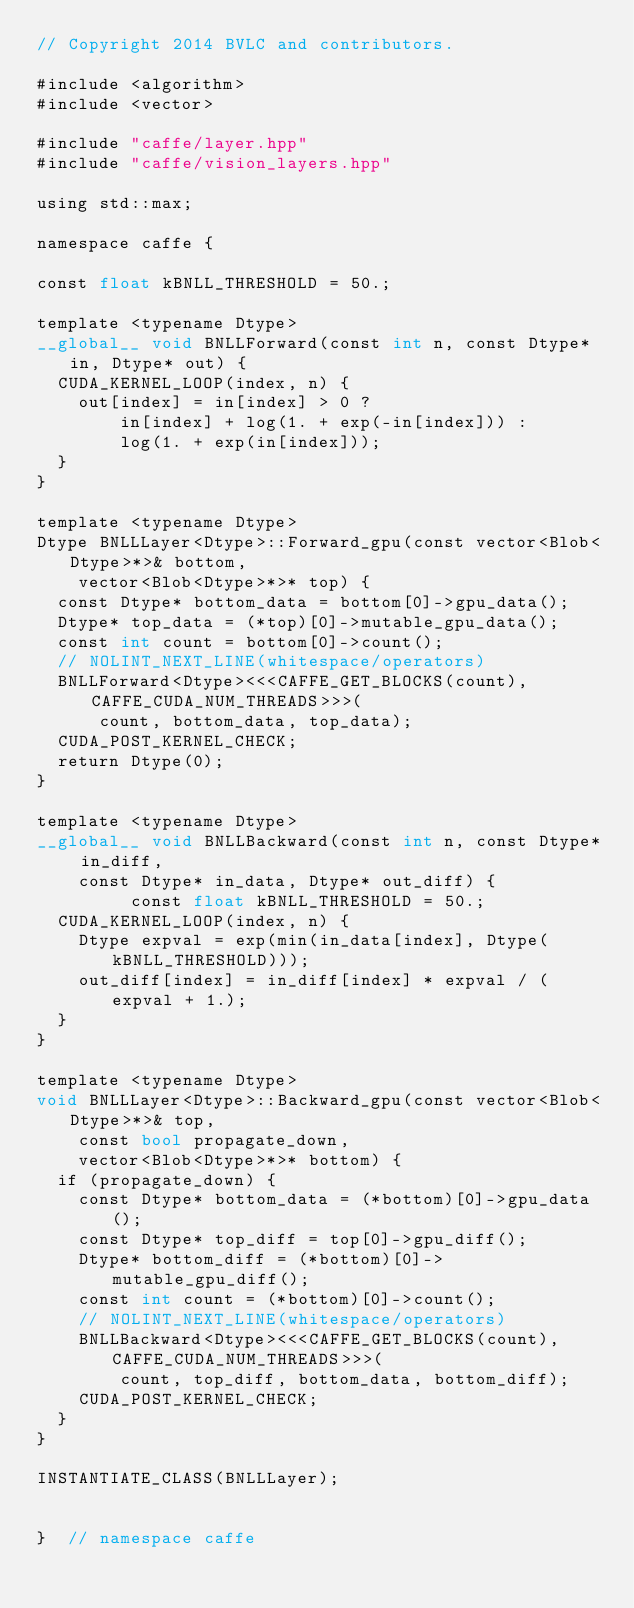<code> <loc_0><loc_0><loc_500><loc_500><_Cuda_>// Copyright 2014 BVLC and contributors.

#include <algorithm>
#include <vector>

#include "caffe/layer.hpp"
#include "caffe/vision_layers.hpp"

using std::max;

namespace caffe {

const float kBNLL_THRESHOLD = 50.;

template <typename Dtype>
__global__ void BNLLForward(const int n, const Dtype* in, Dtype* out) {
  CUDA_KERNEL_LOOP(index, n) {
    out[index] = in[index] > 0 ?
        in[index] + log(1. + exp(-in[index])) :
        log(1. + exp(in[index]));
  }
}

template <typename Dtype>
Dtype BNLLLayer<Dtype>::Forward_gpu(const vector<Blob<Dtype>*>& bottom,
    vector<Blob<Dtype>*>* top) {
  const Dtype* bottom_data = bottom[0]->gpu_data();
  Dtype* top_data = (*top)[0]->mutable_gpu_data();
  const int count = bottom[0]->count();
  // NOLINT_NEXT_LINE(whitespace/operators)
  BNLLForward<Dtype><<<CAFFE_GET_BLOCKS(count), CAFFE_CUDA_NUM_THREADS>>>(
      count, bottom_data, top_data);
  CUDA_POST_KERNEL_CHECK;
  return Dtype(0);
}

template <typename Dtype>
__global__ void BNLLBackward(const int n, const Dtype* in_diff,
    const Dtype* in_data, Dtype* out_diff) {
		 const float kBNLL_THRESHOLD = 50.;
  CUDA_KERNEL_LOOP(index, n) {
    Dtype expval = exp(min(in_data[index], Dtype(kBNLL_THRESHOLD)));
    out_diff[index] = in_diff[index] * expval / (expval + 1.);
  }
}

template <typename Dtype>
void BNLLLayer<Dtype>::Backward_gpu(const vector<Blob<Dtype>*>& top,
    const bool propagate_down,
    vector<Blob<Dtype>*>* bottom) {
  if (propagate_down) {
    const Dtype* bottom_data = (*bottom)[0]->gpu_data();
    const Dtype* top_diff = top[0]->gpu_diff();
    Dtype* bottom_diff = (*bottom)[0]->mutable_gpu_diff();
    const int count = (*bottom)[0]->count();
    // NOLINT_NEXT_LINE(whitespace/operators)
    BNLLBackward<Dtype><<<CAFFE_GET_BLOCKS(count), CAFFE_CUDA_NUM_THREADS>>>(
        count, top_diff, bottom_data, bottom_diff);
    CUDA_POST_KERNEL_CHECK;
  }
}

INSTANTIATE_CLASS(BNLLLayer);


}  // namespace caffe
</code> 